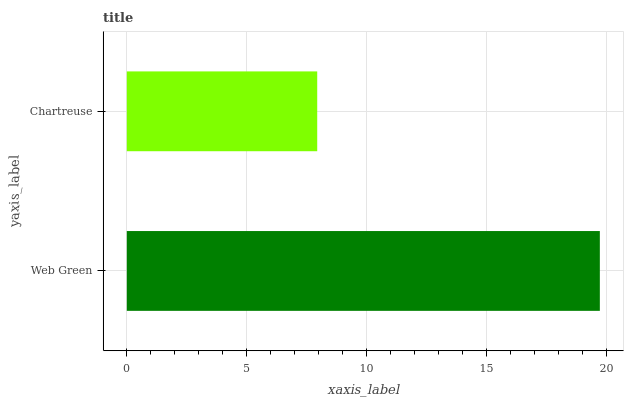Is Chartreuse the minimum?
Answer yes or no. Yes. Is Web Green the maximum?
Answer yes or no. Yes. Is Chartreuse the maximum?
Answer yes or no. No. Is Web Green greater than Chartreuse?
Answer yes or no. Yes. Is Chartreuse less than Web Green?
Answer yes or no. Yes. Is Chartreuse greater than Web Green?
Answer yes or no. No. Is Web Green less than Chartreuse?
Answer yes or no. No. Is Web Green the high median?
Answer yes or no. Yes. Is Chartreuse the low median?
Answer yes or no. Yes. Is Chartreuse the high median?
Answer yes or no. No. Is Web Green the low median?
Answer yes or no. No. 